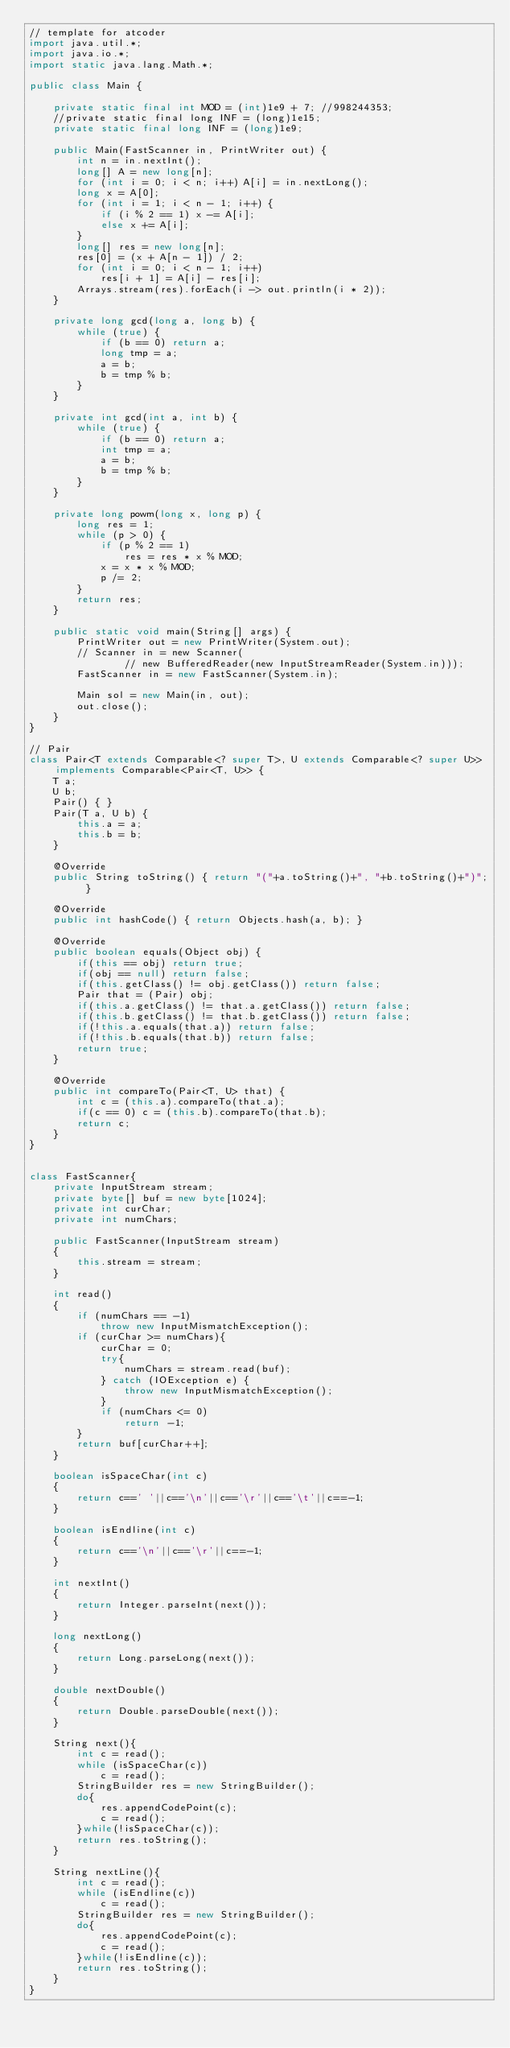<code> <loc_0><loc_0><loc_500><loc_500><_Java_>// template for atcoder
import java.util.*;
import java.io.*;
import static java.lang.Math.*;

public class Main {

    private static final int MOD = (int)1e9 + 7; //998244353;
    //private static final long INF = (long)1e15;
    private static final long INF = (long)1e9;

    public Main(FastScanner in, PrintWriter out) {
        int n = in.nextInt();
        long[] A = new long[n];
        for (int i = 0; i < n; i++) A[i] = in.nextLong();
        long x = A[0];
        for (int i = 1; i < n - 1; i++) {
            if (i % 2 == 1) x -= A[i];
            else x += A[i];
        }
        long[] res = new long[n];
        res[0] = (x + A[n - 1]) / 2;
        for (int i = 0; i < n - 1; i++)
            res[i + 1] = A[i] - res[i];
        Arrays.stream(res).forEach(i -> out.println(i * 2));
    }

    private long gcd(long a, long b) {
        while (true) {
            if (b == 0) return a;
            long tmp = a;
            a = b;
            b = tmp % b;
        }
    }

    private int gcd(int a, int b) {
        while (true) {
            if (b == 0) return a;
            int tmp = a;
            a = b;
            b = tmp % b;
        }
    }

    private long powm(long x, long p) {
        long res = 1;
        while (p > 0) {
            if (p % 2 == 1)
                res = res * x % MOD;
            x = x * x % MOD;
            p /= 2;
        }
        return res;
    }

    public static void main(String[] args) {
        PrintWriter out = new PrintWriter(System.out);
        // Scanner in = new Scanner(
                // new BufferedReader(new InputStreamReader(System.in)));
        FastScanner in = new FastScanner(System.in);

        Main sol = new Main(in, out);
        out.close();
    }
}

// Pair
class Pair<T extends Comparable<? super T>, U extends Comparable<? super U>> implements Comparable<Pair<T, U>> {
    T a;
    U b;
    Pair() { }
    Pair(T a, U b) {
        this.a = a;
        this.b = b;
    }

    @Override
    public String toString() { return "("+a.toString()+", "+b.toString()+")"; }

    @Override
    public int hashCode() { return Objects.hash(a, b); }

    @Override
    public boolean equals(Object obj) {
        if(this == obj) return true;
        if(obj == null) return false;
        if(this.getClass() != obj.getClass()) return false;
        Pair that = (Pair) obj;
        if(this.a.getClass() != that.a.getClass()) return false;
        if(this.b.getClass() != that.b.getClass()) return false;
        if(!this.a.equals(that.a)) return false;
        if(!this.b.equals(that.b)) return false;
        return true;
    }

    @Override
    public int compareTo(Pair<T, U> that) {
        int c = (this.a).compareTo(that.a);
        if(c == 0) c = (this.b).compareTo(that.b);
        return c;
    }
}


class FastScanner{
    private InputStream stream;
    private byte[] buf = new byte[1024];
    private int curChar;
    private int numChars;

    public FastScanner(InputStream stream)
    {
        this.stream = stream;
    }

    int read()
    {
        if (numChars == -1)
            throw new InputMismatchException();
        if (curChar >= numChars){
            curChar = 0;
            try{
                numChars = stream.read(buf);
            } catch (IOException e) {
                throw new InputMismatchException();
            }
            if (numChars <= 0)
                return -1;
        }
        return buf[curChar++];
    }

    boolean isSpaceChar(int c)
    {
        return c==' '||c=='\n'||c=='\r'||c=='\t'||c==-1;
    }

    boolean isEndline(int c)
    {
        return c=='\n'||c=='\r'||c==-1;
    }

    int nextInt()
    {
        return Integer.parseInt(next());
    }

    long nextLong()
    {
        return Long.parseLong(next());
    }

    double nextDouble()
    {
        return Double.parseDouble(next());
    }

    String next(){
        int c = read();
        while (isSpaceChar(c))
            c = read();
        StringBuilder res = new StringBuilder();
        do{
            res.appendCodePoint(c);
            c = read();
        }while(!isSpaceChar(c));
        return res.toString();
    }

    String nextLine(){
        int c = read();
        while (isEndline(c))
            c = read();
        StringBuilder res = new StringBuilder();
        do{
            res.appendCodePoint(c);
            c = read();
        }while(!isEndline(c));
        return res.toString();
    }
}
</code> 